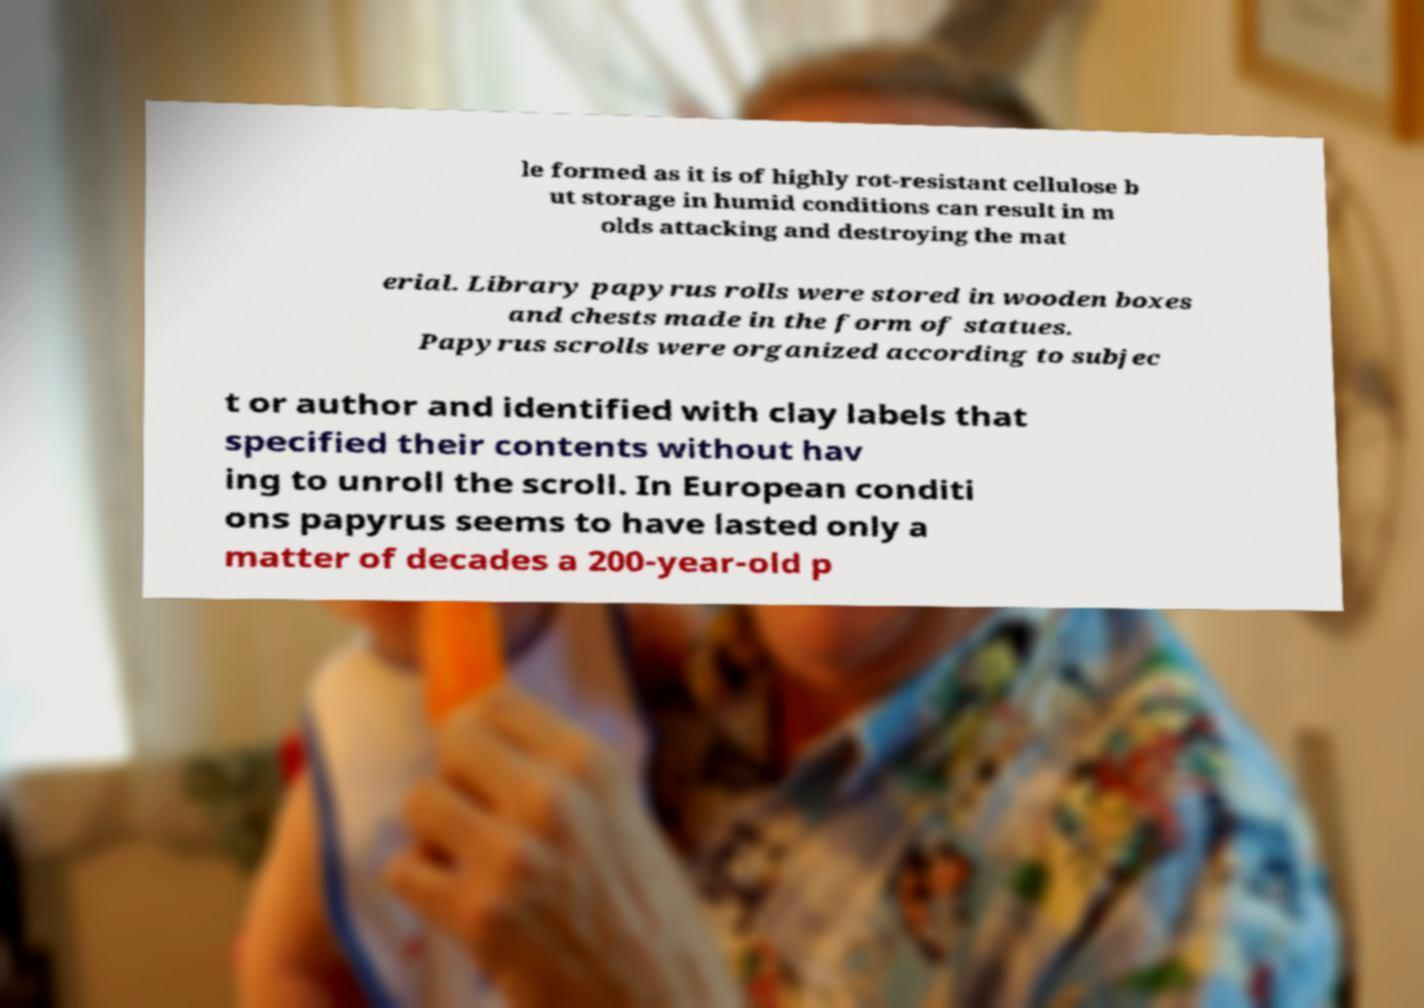Please read and relay the text visible in this image. What does it say? le formed as it is of highly rot-resistant cellulose b ut storage in humid conditions can result in m olds attacking and destroying the mat erial. Library papyrus rolls were stored in wooden boxes and chests made in the form of statues. Papyrus scrolls were organized according to subjec t or author and identified with clay labels that specified their contents without hav ing to unroll the scroll. In European conditi ons papyrus seems to have lasted only a matter of decades a 200-year-old p 